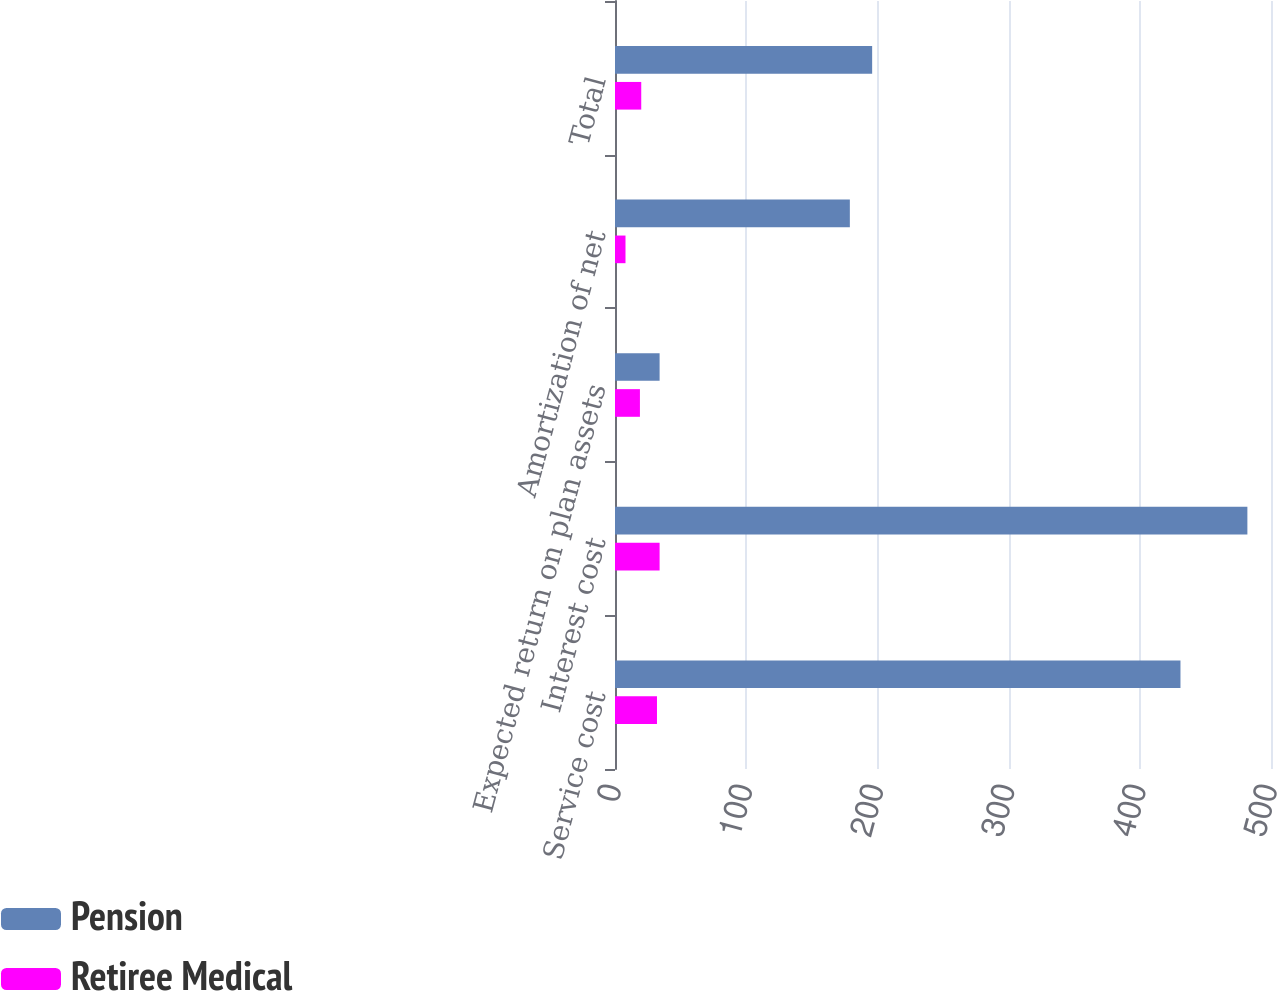<chart> <loc_0><loc_0><loc_500><loc_500><stacked_bar_chart><ecel><fcel>Service cost<fcel>Interest cost<fcel>Expected return on plan assets<fcel>Amortization of net<fcel>Total<nl><fcel>Pension<fcel>431<fcel>482<fcel>34<fcel>179<fcel>196<nl><fcel>Retiree Medical<fcel>32<fcel>34<fcel>19<fcel>8<fcel>20<nl></chart> 